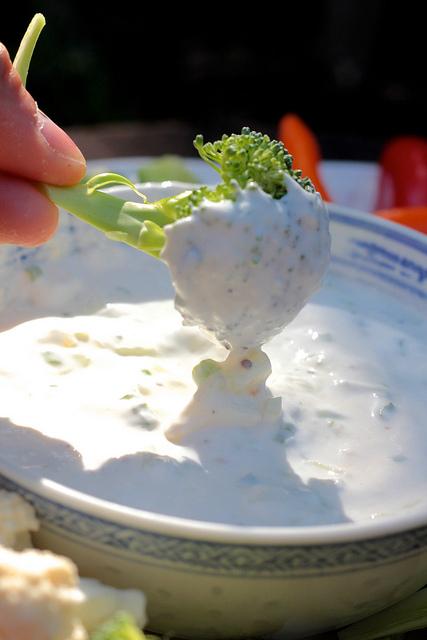Does the person holding the broccoli have dry cuticles?
Short answer required. Yes. When will this be served next?
Write a very short answer. Now. Is a shadow cast?
Answer briefly. Yes. 